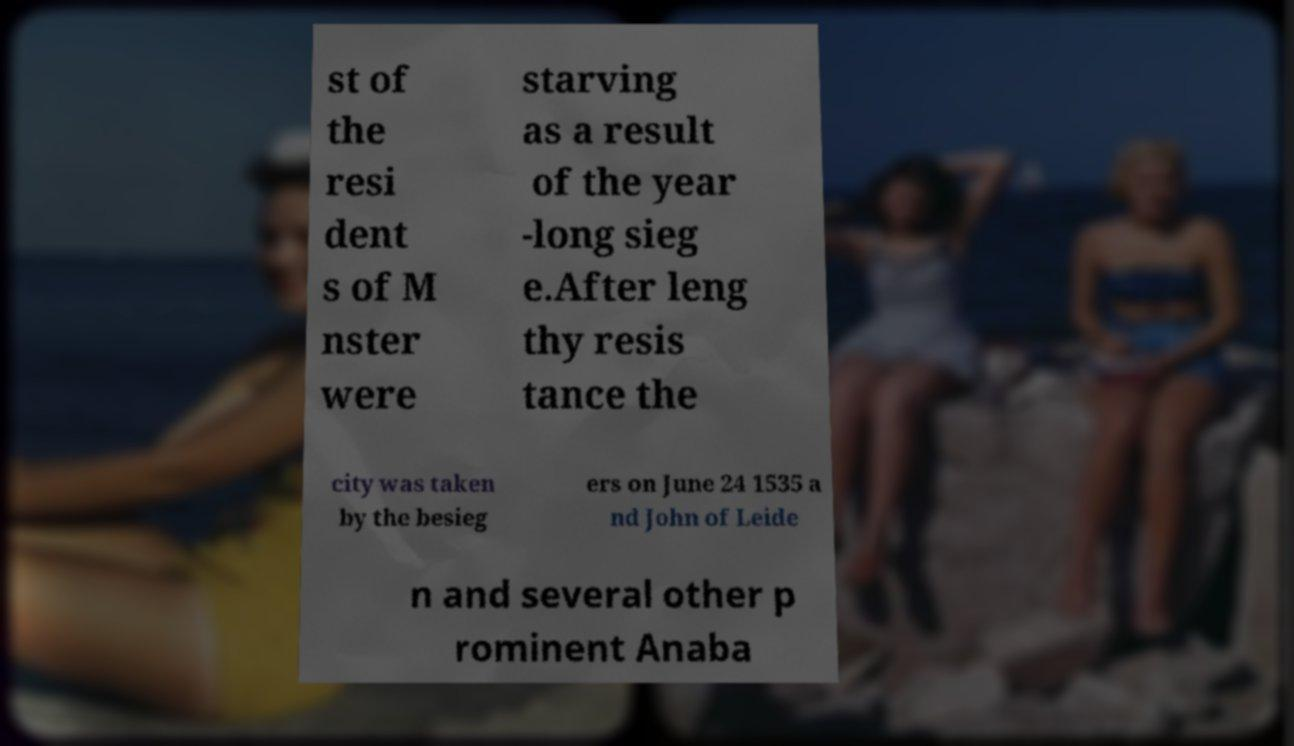I need the written content from this picture converted into text. Can you do that? st of the resi dent s of M nster were starving as a result of the year -long sieg e.After leng thy resis tance the city was taken by the besieg ers on June 24 1535 a nd John of Leide n and several other p rominent Anaba 